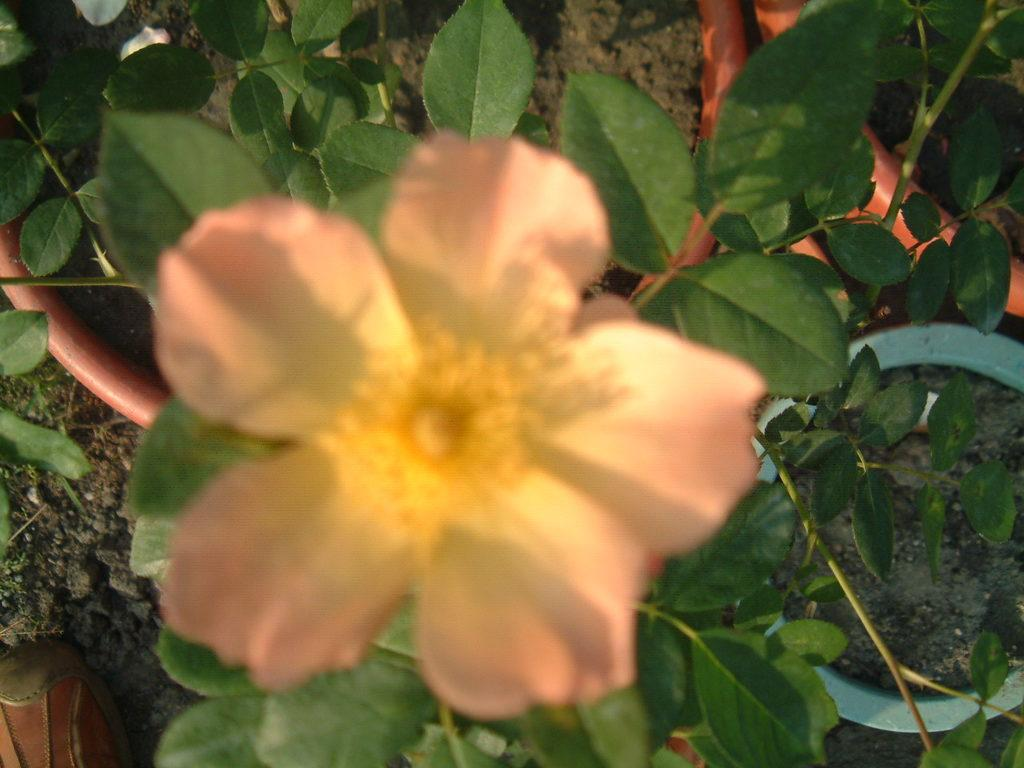What type of living organism is present in the image? There is a plant in the image. What specific feature can be observed on the plant? The plant has a flower. What else can be seen in the middle of the image? There is a pipe in the middle of the image. What type of loaf is being used to decorate the crown in the image? There is no loaf or crown present in the image; it features a plant with a flower and a pipe. 